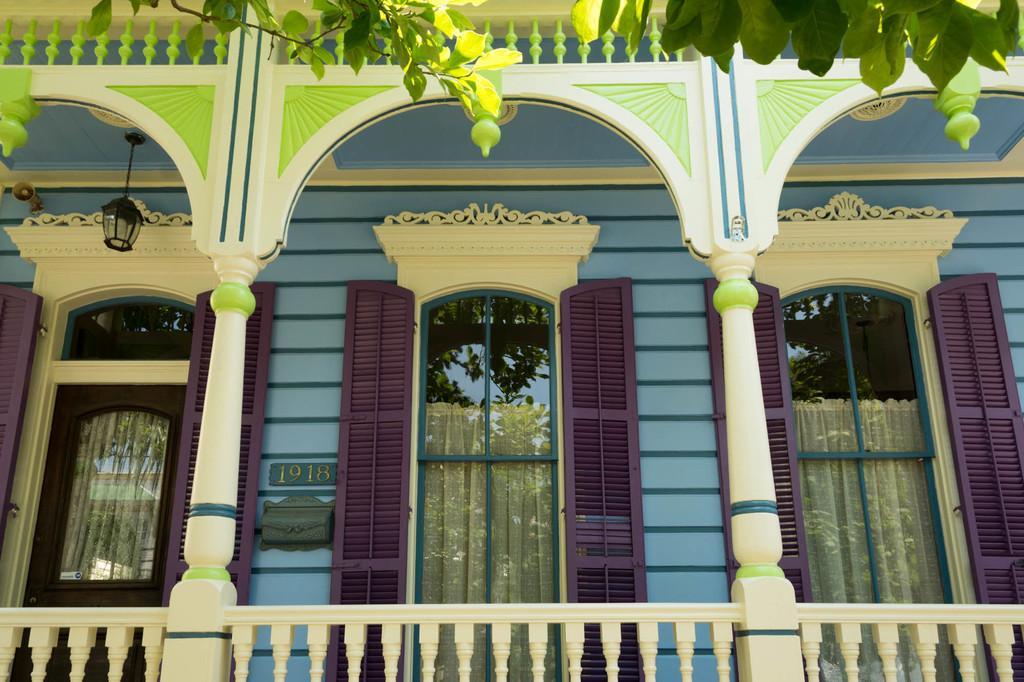Can you describe this image briefly? In this picture we can observe a building. There are two pillars. We can observe a door on the left side and two windows. We can observe a light hanging from the ceiling. There is a tree. The building is in blue and green color. There is a railing which is in cream color. 